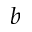Convert formula to latex. <formula><loc_0><loc_0><loc_500><loc_500>b</formula> 